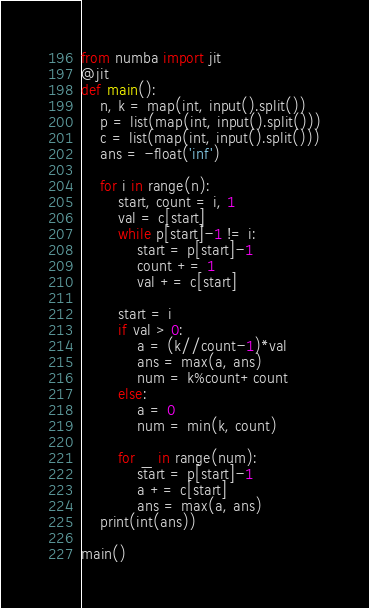Convert code to text. <code><loc_0><loc_0><loc_500><loc_500><_Python_>from numba import jit
@jit
def main():
    n, k = map(int, input().split())
    p = list(map(int, input().split()))
    c = list(map(int, input().split()))
    ans = -float('inf')
    
    for i in range(n):
        start, count = i, 1
        val = c[start]
        while p[start]-1 != i:
            start = p[start]-1
            count += 1
            val += c[start]

        start = i
        if val > 0:
            a = (k//count-1)*val
            ans = max(a, ans)
            num = k%count+count
        else:
            a = 0
            num = min(k, count)

        for _ in range(num):
            start = p[start]-1
            a += c[start]
            ans = max(a, ans)
    print(int(ans))

main()
</code> 